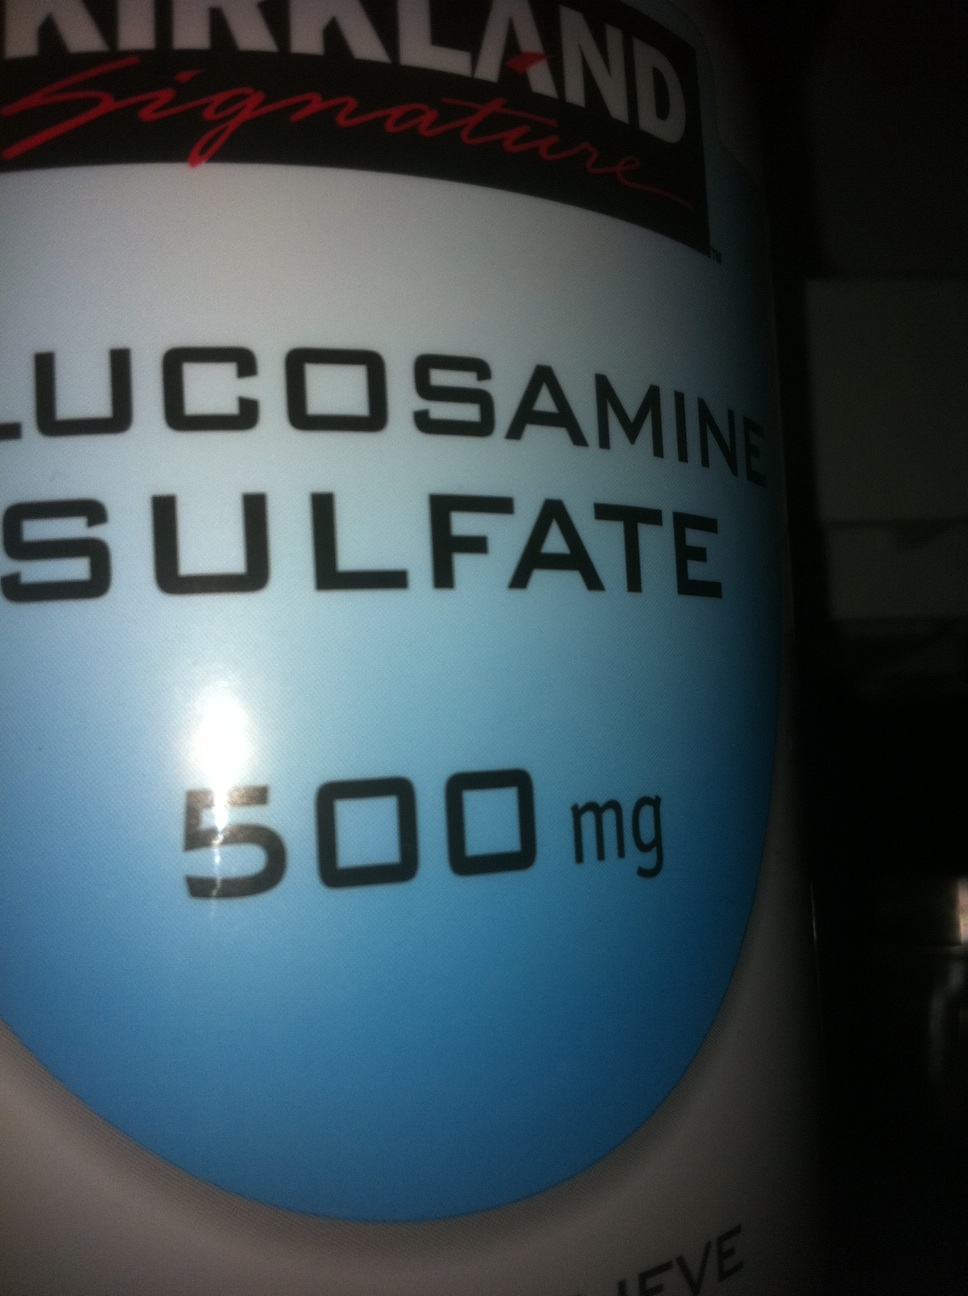Is this product suitable for vegetarians or vegans? Glucosharegpt4v/samine supplements are often derived from shellfish, which means they might not be suitable for vegetarians or vegans. However, there are vegetarian and vegan glucosharegpt4v/samine supplements available that are made from fermented corn or other plant sources. It would be best to check the label or consult the manufacturer to determine the source of glucosharegpt4v/samine in this specific product. 